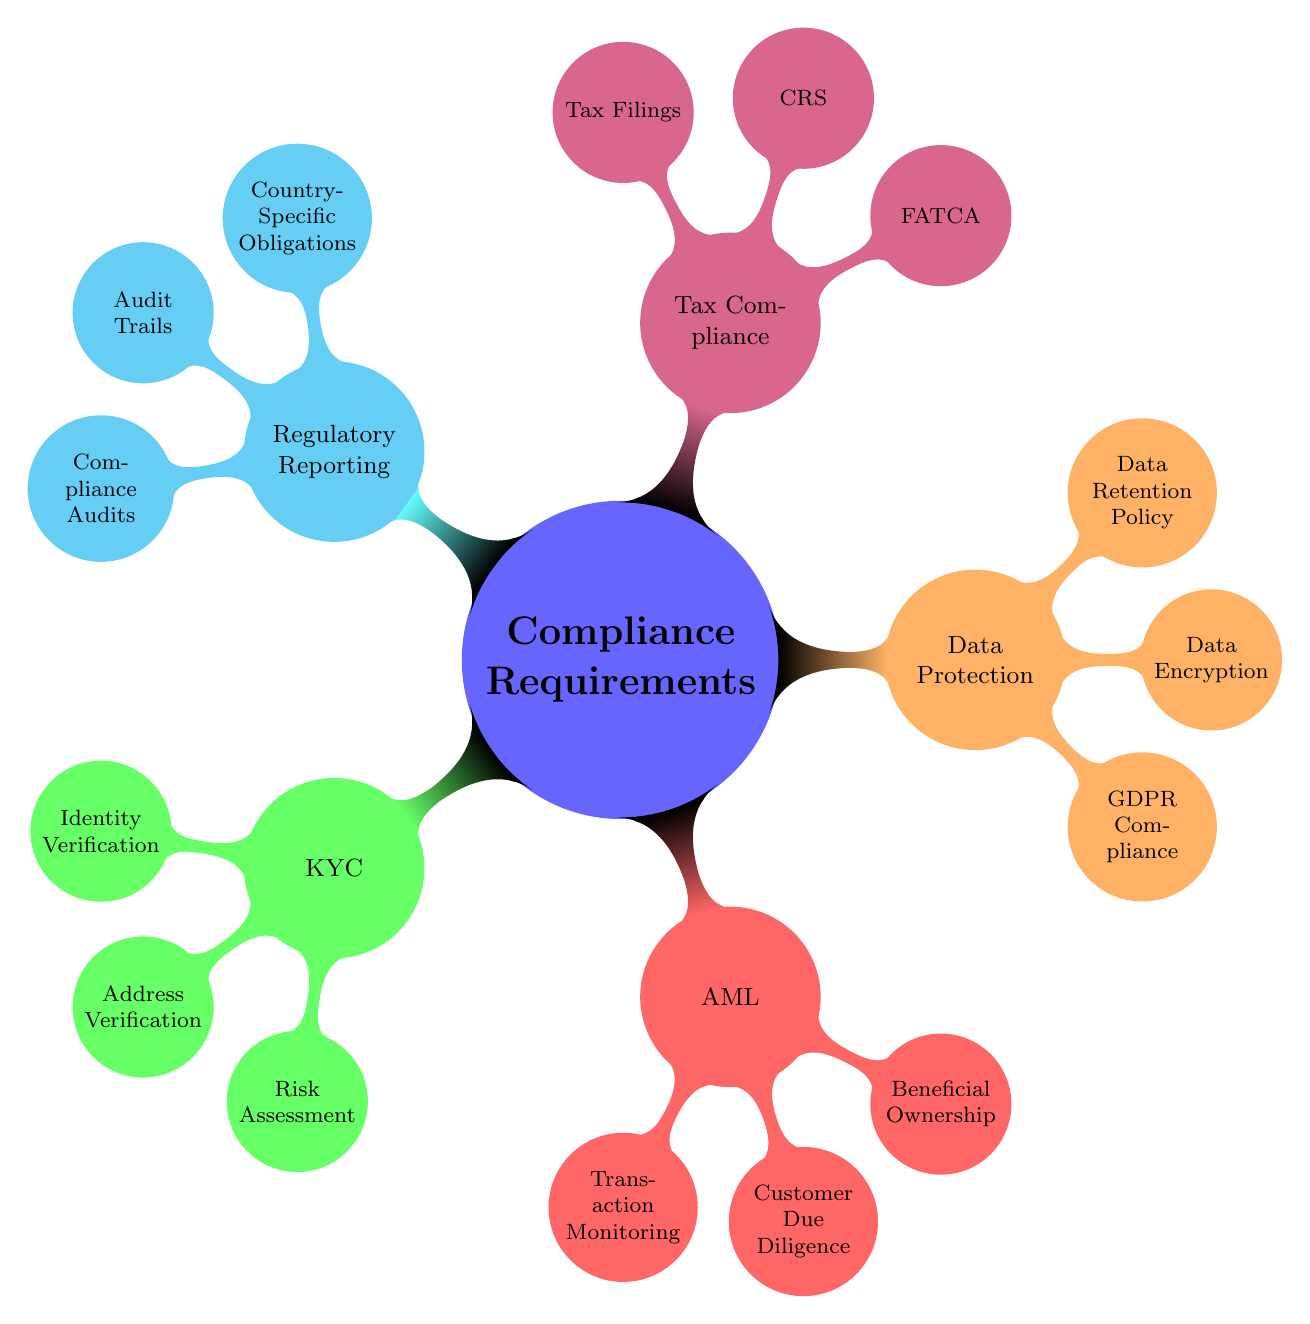What is the main category depicted in the diagram? The main category is visible as the central node labeled "Compliance Requirements".
Answer: Compliance Requirements How many children does "KYC" have? "KYC" has three children: Identity Verification, Address Verification, and Risk Assessment.
Answer: 3 What is the focus of the "AML" section? The "AML" section focuses on Anti-Money Laundering, which includes Transaction Monitoring, Customer Due Diligence, and Beneficial Ownership.
Answer: Anti-Money Laundering What are the types of compliance within the "Data Protection" node? The types include GDPR Compliance, Data Encryption, and Data Retention Policy.
Answer: GDPR Compliance, Data Encryption, Data Retention Policy Which compliance category includes "FATCA"? "FATCA" is included under the "Tax Compliance" category, which also encompasses CRS and Tax Filings.
Answer: Tax Compliance What is the relationship between "Transaction Monitoring" and "Customer Due Diligence"? Both "Transaction Monitoring" and "Customer Due Diligence" are child nodes under the "AML" category.
Answer: Child nodes How many total compliance categories are represented in the diagram? There are five compliance categories: KYC, AML, Data Protection, Tax Compliance, and Regulatory Reporting.
Answer: 5 What specific obligations are found in the "Regulatory Reporting" category? The "Regulatory Reporting" category includes Country-Specific Obligations, Audit Trails, and Compliance Audits.
Answer: Country-Specific Obligations, Audit Trails, Compliance Audits What type of verification is required under "KYC"? "KYC" requires Identity Verification, which can be done through Passport, National ID, or Driver's License.
Answer: Identity Verification 